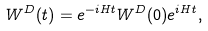Convert formula to latex. <formula><loc_0><loc_0><loc_500><loc_500>W ^ { D } ( t ) = e ^ { - i H t } W ^ { D } ( 0 ) e ^ { i H t } ,</formula> 